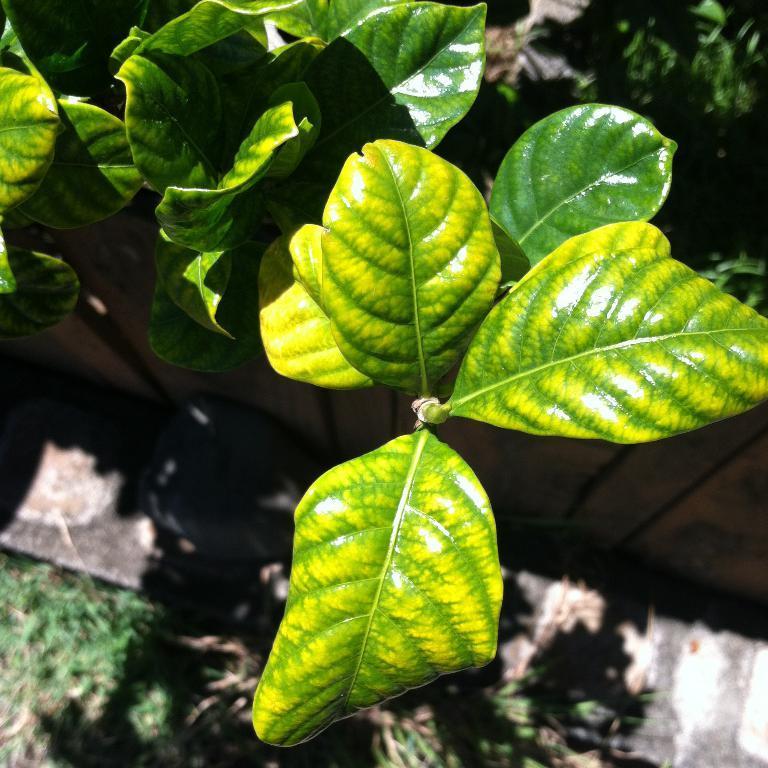How would you summarize this image in a sentence or two? In this picture we can see green leaves. In the background of the image it is blurry. 